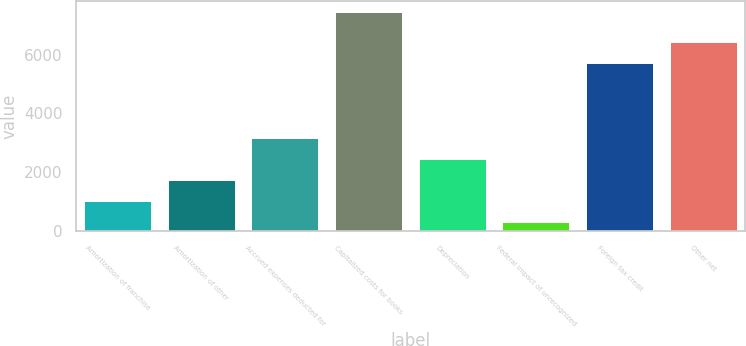Convert chart to OTSL. <chart><loc_0><loc_0><loc_500><loc_500><bar_chart><fcel>Amortization of franchise<fcel>Amortization of other<fcel>Accrued expenses deducted for<fcel>Capitalized costs for books<fcel>Depreciation<fcel>Federal impact of unrecognized<fcel>Foreign tax credit<fcel>Other net<nl><fcel>1042.7<fcel>1754.4<fcel>3177.8<fcel>7448<fcel>2466.1<fcel>331<fcel>5719<fcel>6430.7<nl></chart> 